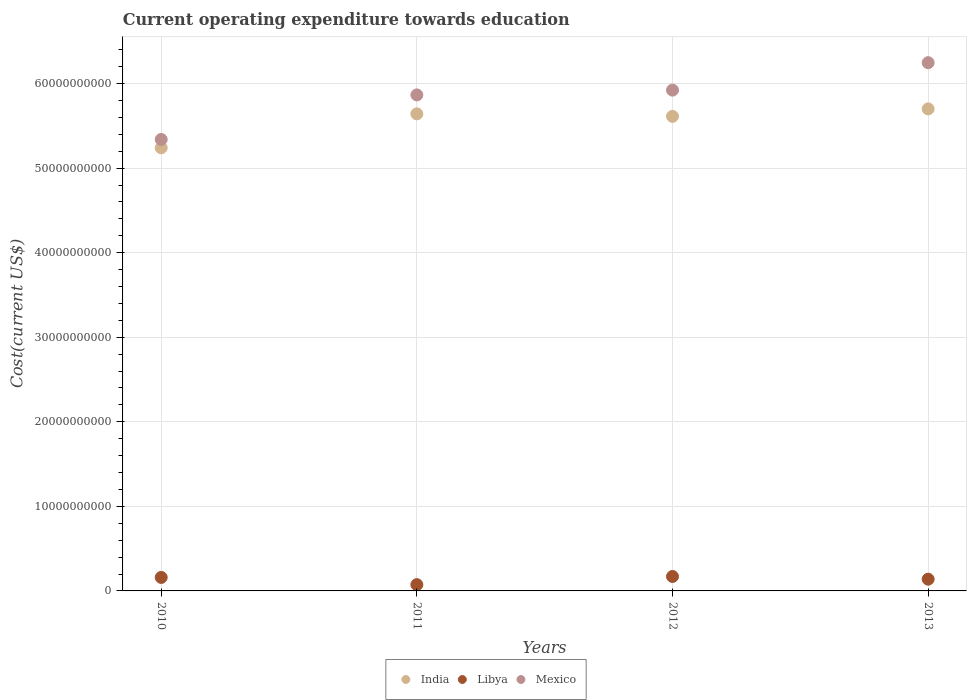Is the number of dotlines equal to the number of legend labels?
Provide a short and direct response. Yes. What is the expenditure towards education in Libya in 2010?
Offer a very short reply. 1.60e+09. Across all years, what is the maximum expenditure towards education in Mexico?
Your response must be concise. 6.25e+1. Across all years, what is the minimum expenditure towards education in India?
Make the answer very short. 5.24e+1. In which year was the expenditure towards education in India maximum?
Your answer should be compact. 2013. In which year was the expenditure towards education in Mexico minimum?
Make the answer very short. 2010. What is the total expenditure towards education in Mexico in the graph?
Your answer should be compact. 2.34e+11. What is the difference between the expenditure towards education in Libya in 2012 and that in 2013?
Provide a succinct answer. 3.21e+08. What is the difference between the expenditure towards education in Libya in 2011 and the expenditure towards education in India in 2010?
Keep it short and to the point. -5.17e+1. What is the average expenditure towards education in Libya per year?
Your answer should be very brief. 1.36e+09. In the year 2013, what is the difference between the expenditure towards education in Mexico and expenditure towards education in Libya?
Give a very brief answer. 6.11e+1. In how many years, is the expenditure towards education in Mexico greater than 36000000000 US$?
Keep it short and to the point. 4. What is the ratio of the expenditure towards education in Libya in 2012 to that in 2013?
Offer a terse response. 1.23. What is the difference between the highest and the second highest expenditure towards education in Mexico?
Keep it short and to the point. 3.24e+09. What is the difference between the highest and the lowest expenditure towards education in India?
Ensure brevity in your answer.  4.60e+09. Is the sum of the expenditure towards education in Mexico in 2011 and 2012 greater than the maximum expenditure towards education in India across all years?
Offer a terse response. Yes. Is it the case that in every year, the sum of the expenditure towards education in India and expenditure towards education in Mexico  is greater than the expenditure towards education in Libya?
Your answer should be compact. Yes. Does the expenditure towards education in Mexico monotonically increase over the years?
Your answer should be very brief. Yes. Is the expenditure towards education in Mexico strictly greater than the expenditure towards education in India over the years?
Give a very brief answer. Yes. How many dotlines are there?
Offer a terse response. 3. How many years are there in the graph?
Your answer should be compact. 4. What is the difference between two consecutive major ticks on the Y-axis?
Your response must be concise. 1.00e+1. Are the values on the major ticks of Y-axis written in scientific E-notation?
Your response must be concise. No. Does the graph contain any zero values?
Provide a succinct answer. No. How many legend labels are there?
Your response must be concise. 3. How are the legend labels stacked?
Your answer should be very brief. Horizontal. What is the title of the graph?
Offer a terse response. Current operating expenditure towards education. Does "Papua New Guinea" appear as one of the legend labels in the graph?
Keep it short and to the point. No. What is the label or title of the X-axis?
Ensure brevity in your answer.  Years. What is the label or title of the Y-axis?
Your response must be concise. Cost(current US$). What is the Cost(current US$) in India in 2010?
Your answer should be compact. 5.24e+1. What is the Cost(current US$) in Libya in 2010?
Provide a short and direct response. 1.60e+09. What is the Cost(current US$) in Mexico in 2010?
Your response must be concise. 5.34e+1. What is the Cost(current US$) in India in 2011?
Your response must be concise. 5.64e+1. What is the Cost(current US$) in Libya in 2011?
Your response must be concise. 7.43e+08. What is the Cost(current US$) of Mexico in 2011?
Offer a terse response. 5.87e+1. What is the Cost(current US$) in India in 2012?
Your response must be concise. 5.61e+1. What is the Cost(current US$) of Libya in 2012?
Your response must be concise. 1.71e+09. What is the Cost(current US$) of Mexico in 2012?
Offer a terse response. 5.92e+1. What is the Cost(current US$) of India in 2013?
Keep it short and to the point. 5.70e+1. What is the Cost(current US$) of Libya in 2013?
Give a very brief answer. 1.39e+09. What is the Cost(current US$) in Mexico in 2013?
Your response must be concise. 6.25e+1. Across all years, what is the maximum Cost(current US$) of India?
Your response must be concise. 5.70e+1. Across all years, what is the maximum Cost(current US$) in Libya?
Keep it short and to the point. 1.71e+09. Across all years, what is the maximum Cost(current US$) of Mexico?
Make the answer very short. 6.25e+1. Across all years, what is the minimum Cost(current US$) in India?
Your answer should be compact. 5.24e+1. Across all years, what is the minimum Cost(current US$) of Libya?
Give a very brief answer. 7.43e+08. Across all years, what is the minimum Cost(current US$) in Mexico?
Keep it short and to the point. 5.34e+1. What is the total Cost(current US$) of India in the graph?
Provide a short and direct response. 2.22e+11. What is the total Cost(current US$) in Libya in the graph?
Keep it short and to the point. 5.44e+09. What is the total Cost(current US$) in Mexico in the graph?
Your answer should be compact. 2.34e+11. What is the difference between the Cost(current US$) in India in 2010 and that in 2011?
Your response must be concise. -4.01e+09. What is the difference between the Cost(current US$) in Libya in 2010 and that in 2011?
Give a very brief answer. 8.55e+08. What is the difference between the Cost(current US$) in Mexico in 2010 and that in 2011?
Offer a very short reply. -5.27e+09. What is the difference between the Cost(current US$) in India in 2010 and that in 2012?
Your response must be concise. -3.72e+09. What is the difference between the Cost(current US$) in Libya in 2010 and that in 2012?
Make the answer very short. -1.12e+08. What is the difference between the Cost(current US$) in Mexico in 2010 and that in 2012?
Your answer should be compact. -5.83e+09. What is the difference between the Cost(current US$) in India in 2010 and that in 2013?
Ensure brevity in your answer.  -4.60e+09. What is the difference between the Cost(current US$) in Libya in 2010 and that in 2013?
Offer a terse response. 2.09e+08. What is the difference between the Cost(current US$) of Mexico in 2010 and that in 2013?
Offer a terse response. -9.08e+09. What is the difference between the Cost(current US$) of India in 2011 and that in 2012?
Give a very brief answer. 2.94e+08. What is the difference between the Cost(current US$) in Libya in 2011 and that in 2012?
Make the answer very short. -9.67e+08. What is the difference between the Cost(current US$) in Mexico in 2011 and that in 2012?
Provide a short and direct response. -5.67e+08. What is the difference between the Cost(current US$) in India in 2011 and that in 2013?
Your answer should be very brief. -5.89e+08. What is the difference between the Cost(current US$) of Libya in 2011 and that in 2013?
Your response must be concise. -6.46e+08. What is the difference between the Cost(current US$) in Mexico in 2011 and that in 2013?
Your response must be concise. -3.81e+09. What is the difference between the Cost(current US$) of India in 2012 and that in 2013?
Your answer should be very brief. -8.83e+08. What is the difference between the Cost(current US$) in Libya in 2012 and that in 2013?
Your response must be concise. 3.21e+08. What is the difference between the Cost(current US$) of Mexico in 2012 and that in 2013?
Provide a succinct answer. -3.24e+09. What is the difference between the Cost(current US$) in India in 2010 and the Cost(current US$) in Libya in 2011?
Offer a terse response. 5.17e+1. What is the difference between the Cost(current US$) in India in 2010 and the Cost(current US$) in Mexico in 2011?
Make the answer very short. -6.25e+09. What is the difference between the Cost(current US$) of Libya in 2010 and the Cost(current US$) of Mexico in 2011?
Provide a short and direct response. -5.71e+1. What is the difference between the Cost(current US$) in India in 2010 and the Cost(current US$) in Libya in 2012?
Offer a terse response. 5.07e+1. What is the difference between the Cost(current US$) in India in 2010 and the Cost(current US$) in Mexico in 2012?
Offer a very short reply. -6.82e+09. What is the difference between the Cost(current US$) in Libya in 2010 and the Cost(current US$) in Mexico in 2012?
Keep it short and to the point. -5.76e+1. What is the difference between the Cost(current US$) of India in 2010 and the Cost(current US$) of Libya in 2013?
Make the answer very short. 5.10e+1. What is the difference between the Cost(current US$) of India in 2010 and the Cost(current US$) of Mexico in 2013?
Offer a terse response. -1.01e+1. What is the difference between the Cost(current US$) in Libya in 2010 and the Cost(current US$) in Mexico in 2013?
Keep it short and to the point. -6.09e+1. What is the difference between the Cost(current US$) in India in 2011 and the Cost(current US$) in Libya in 2012?
Provide a short and direct response. 5.47e+1. What is the difference between the Cost(current US$) of India in 2011 and the Cost(current US$) of Mexico in 2012?
Make the answer very short. -2.81e+09. What is the difference between the Cost(current US$) of Libya in 2011 and the Cost(current US$) of Mexico in 2012?
Ensure brevity in your answer.  -5.85e+1. What is the difference between the Cost(current US$) in India in 2011 and the Cost(current US$) in Libya in 2013?
Keep it short and to the point. 5.50e+1. What is the difference between the Cost(current US$) in India in 2011 and the Cost(current US$) in Mexico in 2013?
Ensure brevity in your answer.  -6.05e+09. What is the difference between the Cost(current US$) in Libya in 2011 and the Cost(current US$) in Mexico in 2013?
Make the answer very short. -6.17e+1. What is the difference between the Cost(current US$) of India in 2012 and the Cost(current US$) of Libya in 2013?
Ensure brevity in your answer.  5.47e+1. What is the difference between the Cost(current US$) in India in 2012 and the Cost(current US$) in Mexico in 2013?
Provide a succinct answer. -6.35e+09. What is the difference between the Cost(current US$) in Libya in 2012 and the Cost(current US$) in Mexico in 2013?
Provide a short and direct response. -6.08e+1. What is the average Cost(current US$) in India per year?
Your response must be concise. 5.55e+1. What is the average Cost(current US$) in Libya per year?
Keep it short and to the point. 1.36e+09. What is the average Cost(current US$) of Mexico per year?
Your answer should be compact. 5.84e+1. In the year 2010, what is the difference between the Cost(current US$) of India and Cost(current US$) of Libya?
Ensure brevity in your answer.  5.08e+1. In the year 2010, what is the difference between the Cost(current US$) of India and Cost(current US$) of Mexico?
Your answer should be very brief. -9.84e+08. In the year 2010, what is the difference between the Cost(current US$) of Libya and Cost(current US$) of Mexico?
Offer a very short reply. -5.18e+1. In the year 2011, what is the difference between the Cost(current US$) of India and Cost(current US$) of Libya?
Give a very brief answer. 5.57e+1. In the year 2011, what is the difference between the Cost(current US$) in India and Cost(current US$) in Mexico?
Provide a short and direct response. -2.24e+09. In the year 2011, what is the difference between the Cost(current US$) in Libya and Cost(current US$) in Mexico?
Provide a succinct answer. -5.79e+1. In the year 2012, what is the difference between the Cost(current US$) in India and Cost(current US$) in Libya?
Offer a terse response. 5.44e+1. In the year 2012, what is the difference between the Cost(current US$) of India and Cost(current US$) of Mexico?
Keep it short and to the point. -3.10e+09. In the year 2012, what is the difference between the Cost(current US$) of Libya and Cost(current US$) of Mexico?
Your answer should be very brief. -5.75e+1. In the year 2013, what is the difference between the Cost(current US$) of India and Cost(current US$) of Libya?
Offer a very short reply. 5.56e+1. In the year 2013, what is the difference between the Cost(current US$) of India and Cost(current US$) of Mexico?
Offer a very short reply. -5.47e+09. In the year 2013, what is the difference between the Cost(current US$) in Libya and Cost(current US$) in Mexico?
Offer a terse response. -6.11e+1. What is the ratio of the Cost(current US$) in India in 2010 to that in 2011?
Ensure brevity in your answer.  0.93. What is the ratio of the Cost(current US$) in Libya in 2010 to that in 2011?
Ensure brevity in your answer.  2.15. What is the ratio of the Cost(current US$) in Mexico in 2010 to that in 2011?
Make the answer very short. 0.91. What is the ratio of the Cost(current US$) in India in 2010 to that in 2012?
Your answer should be very brief. 0.93. What is the ratio of the Cost(current US$) of Libya in 2010 to that in 2012?
Offer a terse response. 0.93. What is the ratio of the Cost(current US$) of Mexico in 2010 to that in 2012?
Offer a terse response. 0.9. What is the ratio of the Cost(current US$) in India in 2010 to that in 2013?
Your answer should be compact. 0.92. What is the ratio of the Cost(current US$) of Libya in 2010 to that in 2013?
Offer a terse response. 1.15. What is the ratio of the Cost(current US$) in Mexico in 2010 to that in 2013?
Offer a very short reply. 0.85. What is the ratio of the Cost(current US$) of India in 2011 to that in 2012?
Provide a succinct answer. 1.01. What is the ratio of the Cost(current US$) in Libya in 2011 to that in 2012?
Your answer should be compact. 0.43. What is the ratio of the Cost(current US$) of Libya in 2011 to that in 2013?
Give a very brief answer. 0.53. What is the ratio of the Cost(current US$) in Mexico in 2011 to that in 2013?
Offer a terse response. 0.94. What is the ratio of the Cost(current US$) of India in 2012 to that in 2013?
Ensure brevity in your answer.  0.98. What is the ratio of the Cost(current US$) in Libya in 2012 to that in 2013?
Give a very brief answer. 1.23. What is the ratio of the Cost(current US$) in Mexico in 2012 to that in 2013?
Provide a short and direct response. 0.95. What is the difference between the highest and the second highest Cost(current US$) in India?
Provide a succinct answer. 5.89e+08. What is the difference between the highest and the second highest Cost(current US$) in Libya?
Provide a short and direct response. 1.12e+08. What is the difference between the highest and the second highest Cost(current US$) in Mexico?
Make the answer very short. 3.24e+09. What is the difference between the highest and the lowest Cost(current US$) in India?
Ensure brevity in your answer.  4.60e+09. What is the difference between the highest and the lowest Cost(current US$) of Libya?
Keep it short and to the point. 9.67e+08. What is the difference between the highest and the lowest Cost(current US$) of Mexico?
Give a very brief answer. 9.08e+09. 